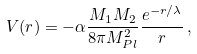<formula> <loc_0><loc_0><loc_500><loc_500>V ( r ) = - \alpha \frac { M _ { 1 } M _ { 2 } } { 8 \pi M _ { P l } ^ { 2 } } \frac { e ^ { - r / \lambda } } { r } \, ,</formula> 